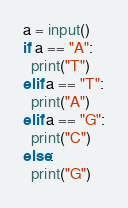Convert code to text. <code><loc_0><loc_0><loc_500><loc_500><_Python_>a = input()
if a == "A":
  print("T")
elif a == "T":
  print("A")
elif a == "G":
  print("C")
else:
  print("G")</code> 